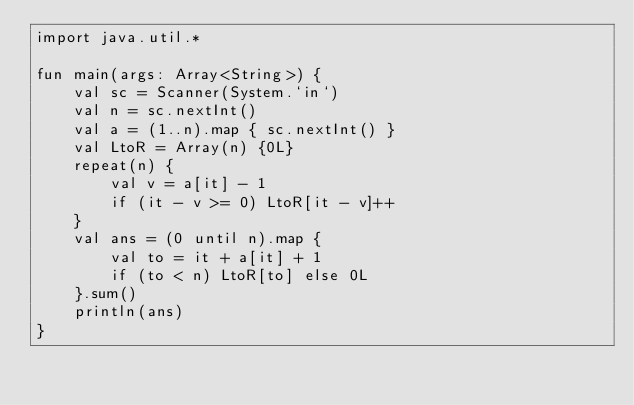Convert code to text. <code><loc_0><loc_0><loc_500><loc_500><_Kotlin_>import java.util.*

fun main(args: Array<String>) {
    val sc = Scanner(System.`in`)
    val n = sc.nextInt()
    val a = (1..n).map { sc.nextInt() }
    val LtoR = Array(n) {0L}
    repeat(n) {
        val v = a[it] - 1
        if (it - v >= 0) LtoR[it - v]++
    }
    val ans = (0 until n).map {
        val to = it + a[it] + 1
        if (to < n) LtoR[to] else 0L
    }.sum()
    println(ans)
}</code> 